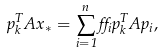<formula> <loc_0><loc_0><loc_500><loc_500>p _ { k } ^ { T } A x _ { * } = \sum _ { i = 1 } ^ { n } \alpha _ { i } p _ { k } ^ { T } A p _ { i } ,</formula> 